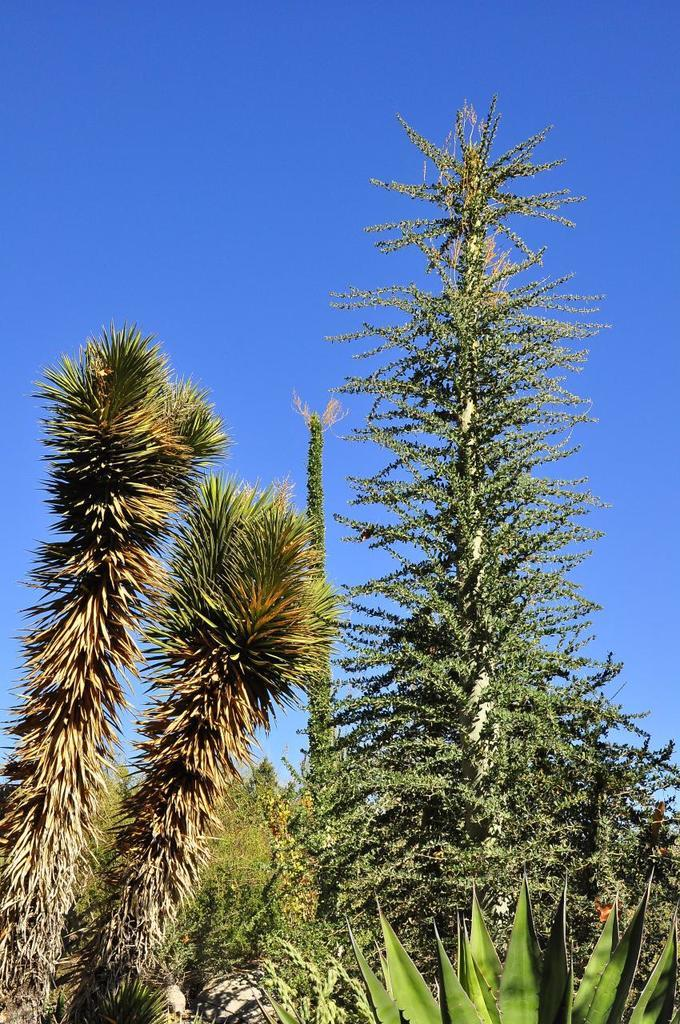What types of vegetation are present at the bottom of the image? There are plants and trees at the bottom of the image. What can be seen in the background of the image? There are clouds in the background of the image. What color is the sky in the image? The sky is blue in the image. How many fingers can be seen holding the sack in the image? There are no fingers or sacks present in the image. What type of necklace is visible around the neck of the tree in the image? There is no necklace or tree with a neck in the image. 